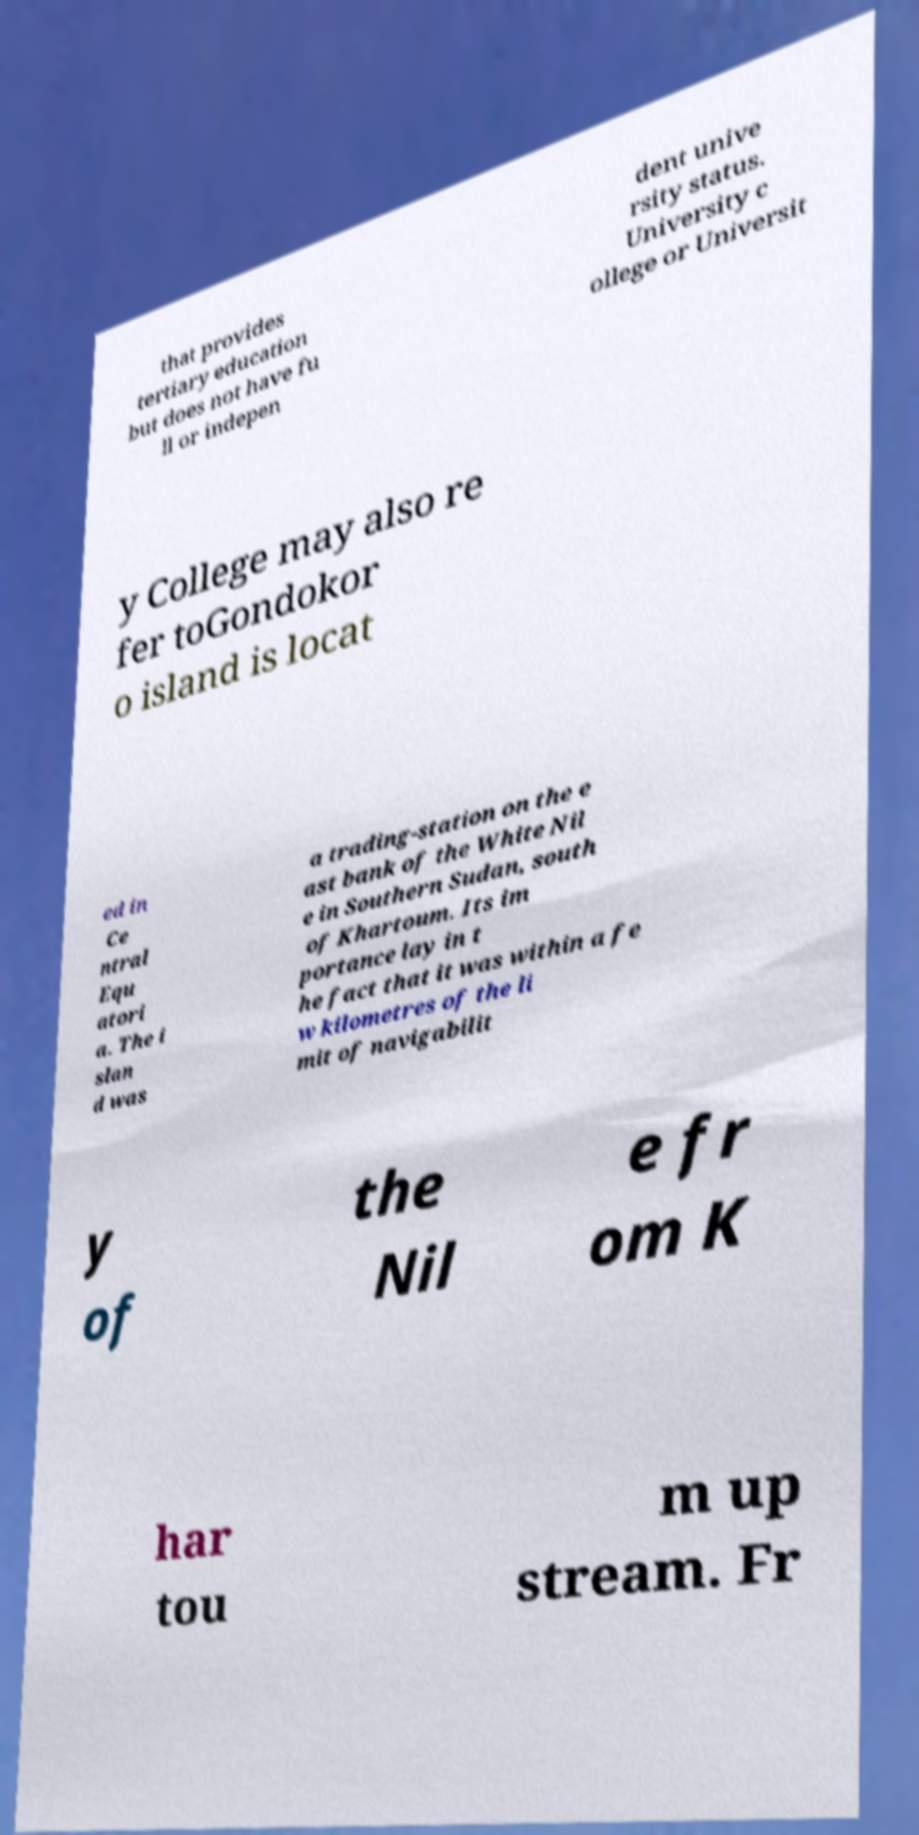Can you accurately transcribe the text from the provided image for me? that provides tertiary education but does not have fu ll or indepen dent unive rsity status. University c ollege or Universit y College may also re fer toGondokor o island is locat ed in Ce ntral Equ atori a. The i slan d was a trading-station on the e ast bank of the White Nil e in Southern Sudan, south of Khartoum. Its im portance lay in t he fact that it was within a fe w kilometres of the li mit of navigabilit y of the Nil e fr om K har tou m up stream. Fr 